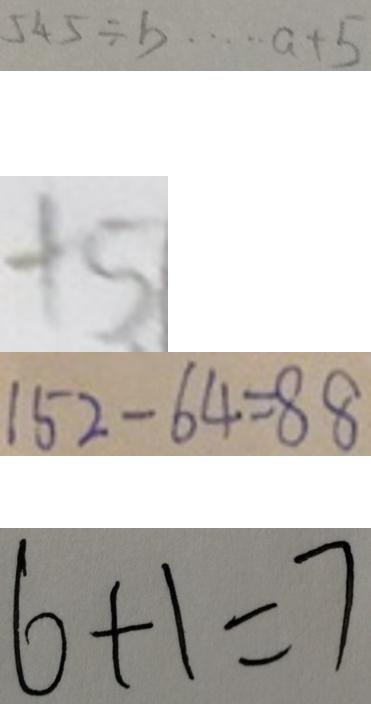Convert formula to latex. <formula><loc_0><loc_0><loc_500><loc_500>5 4 5 \div b \cdots a + 5 
 + 5 
 1 5 2 - 6 4 = 8 8 
 6 + 1 = 7</formula> 